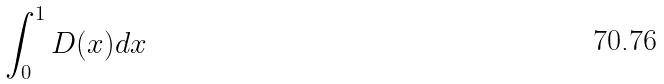<formula> <loc_0><loc_0><loc_500><loc_500>\int _ { 0 } ^ { 1 } D ( x ) d x</formula> 